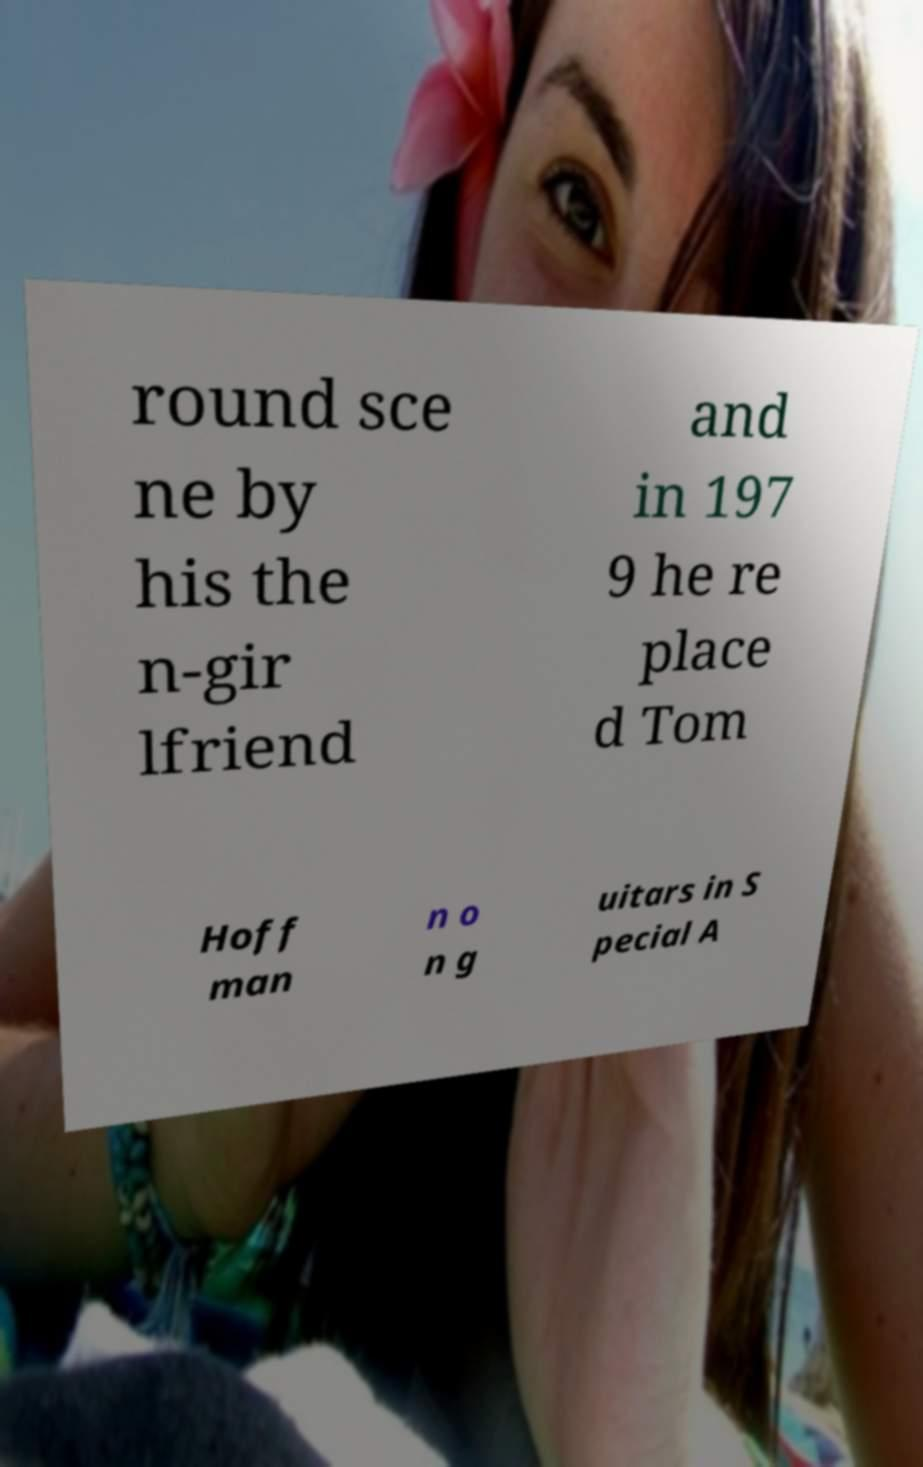For documentation purposes, I need the text within this image transcribed. Could you provide that? round sce ne by his the n-gir lfriend and in 197 9 he re place d Tom Hoff man n o n g uitars in S pecial A 